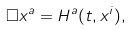<formula> <loc_0><loc_0><loc_500><loc_500>\square x ^ { a } = H ^ { a } ( t , x ^ { i } ) ,</formula> 